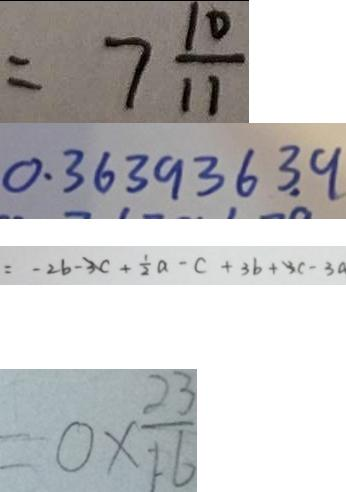Convert formula to latex. <formula><loc_0><loc_0><loc_500><loc_500>= 7 \frac { 1 0 } { 1 1 } 
 0 . 3 6 3 9 3 6 3 . 9 
 = - 2 b - 3 c + \frac { 1 } { 2 } a - c + 3 b + 3 c - 3 a 
 = 0 \times \frac { 2 3 } { 1 6 }</formula> 